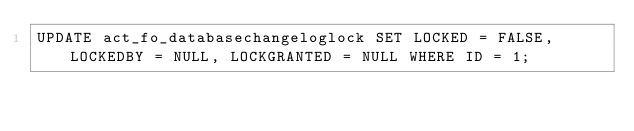Convert code to text. <code><loc_0><loc_0><loc_500><loc_500><_SQL_>UPDATE act_fo_databasechangeloglock SET LOCKED = FALSE, LOCKEDBY = NULL, LOCKGRANTED = NULL WHERE ID = 1;

</code> 